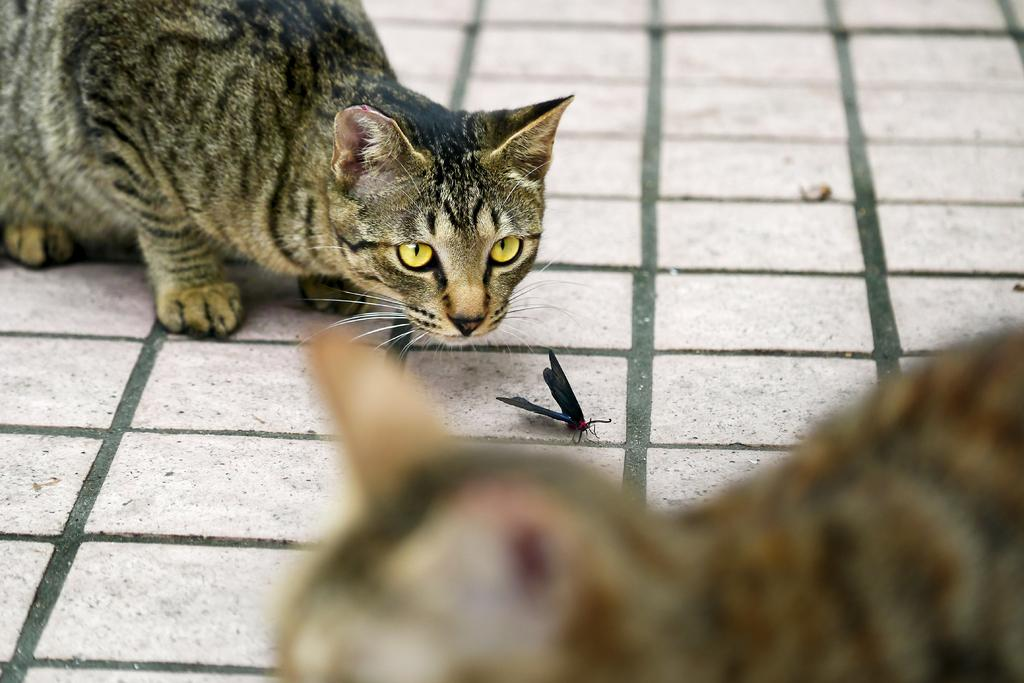How many cats are present in the image? There are two cats in the image. What other living creature can be seen in the image? There is an insect in the image. What type of goat can be seen interacting with the cats in the image? There is no goat present in the image; it only features two cats and an insect. What health benefits might the insect provide to the cats in the image? There is no information about the health benefits of the insect to the cats in the image. 